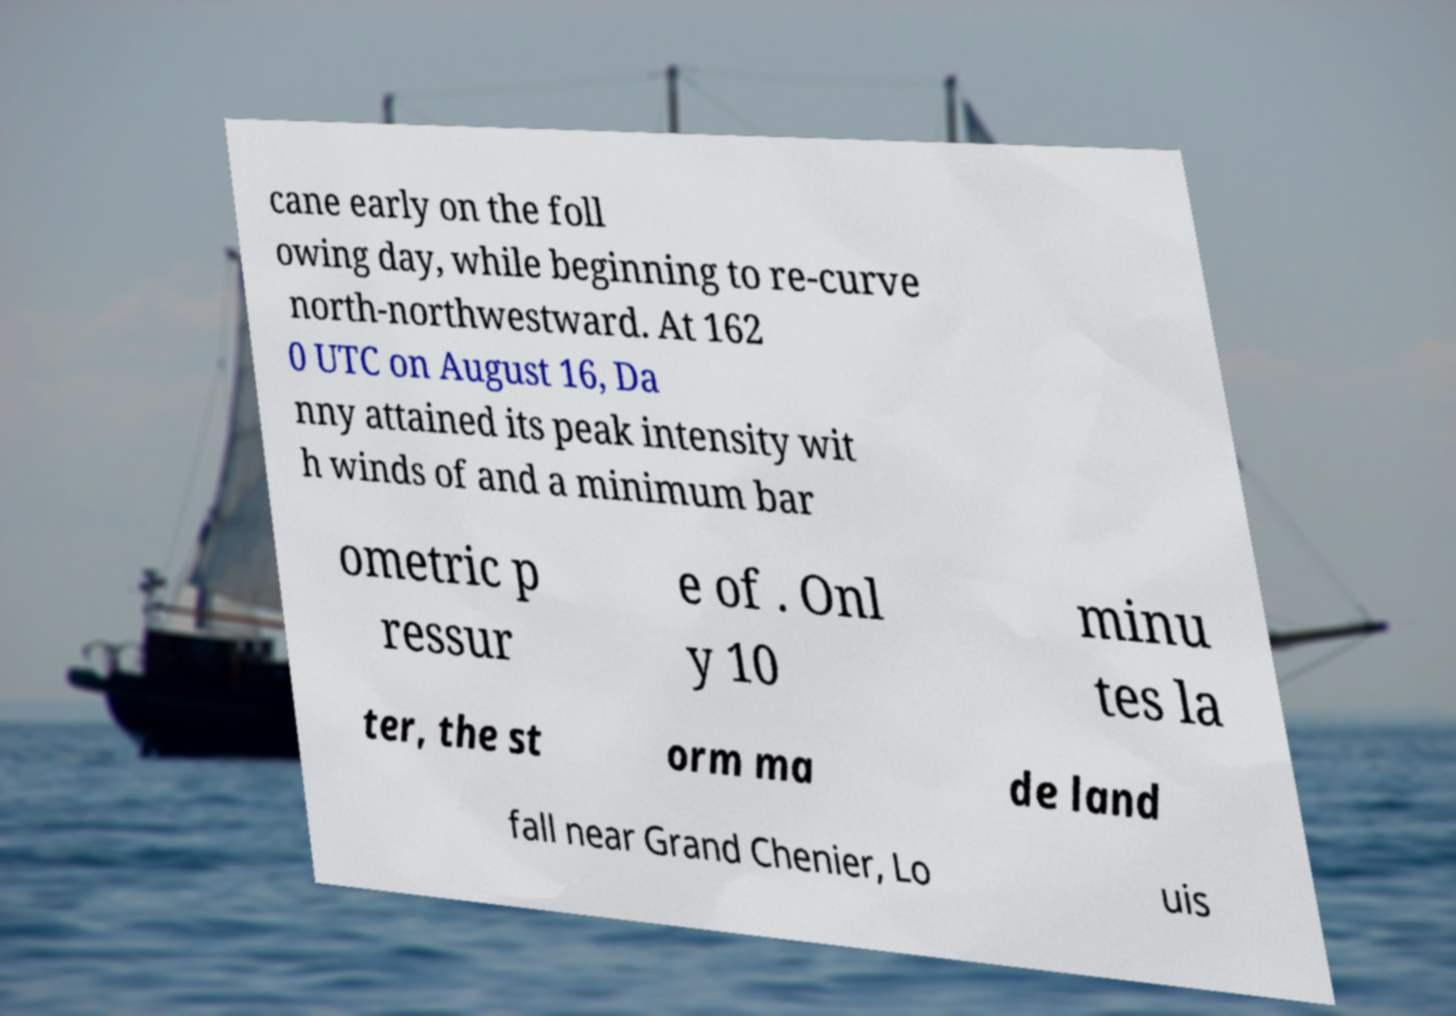What messages or text are displayed in this image? I need them in a readable, typed format. cane early on the foll owing day, while beginning to re-curve north-northwestward. At 162 0 UTC on August 16, Da nny attained its peak intensity wit h winds of and a minimum bar ometric p ressur e of . Onl y 10 minu tes la ter, the st orm ma de land fall near Grand Chenier, Lo uis 